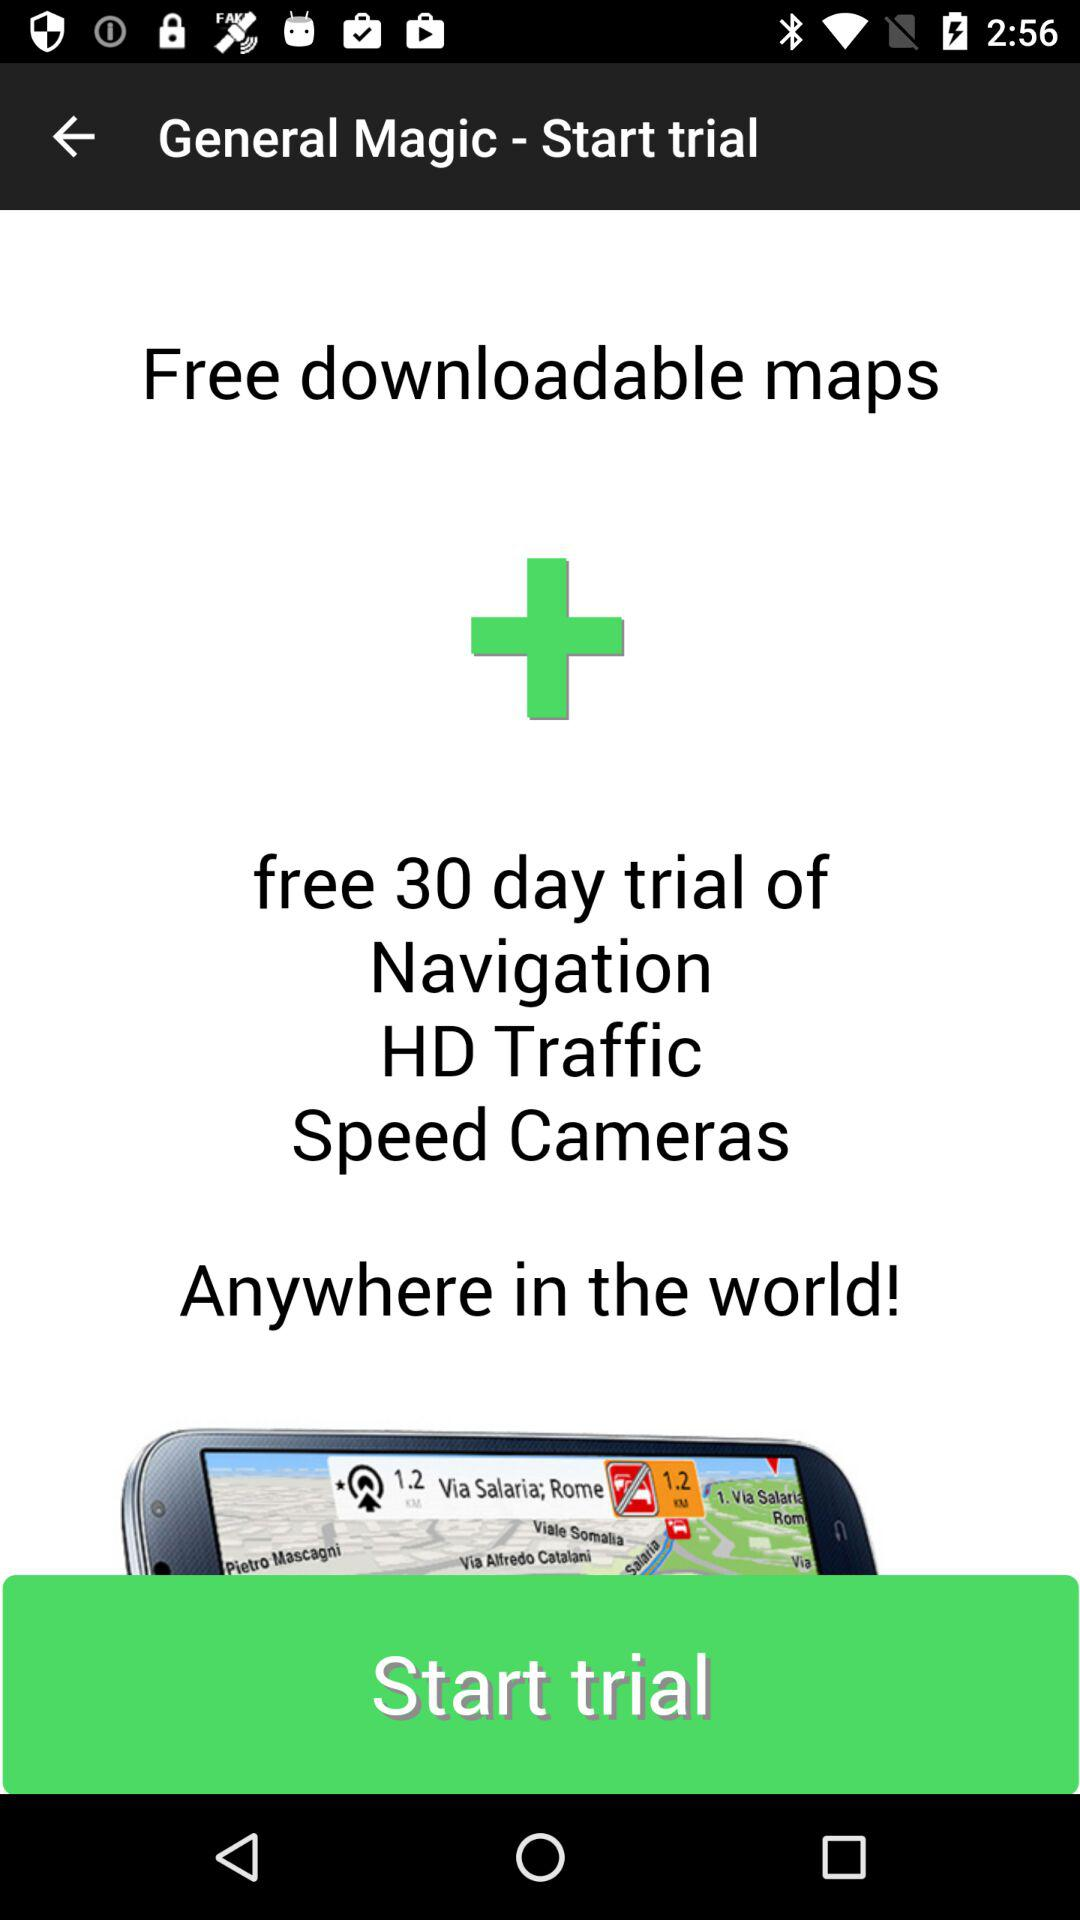How many days are there for a free trial? There are 30 days for a free trial. 